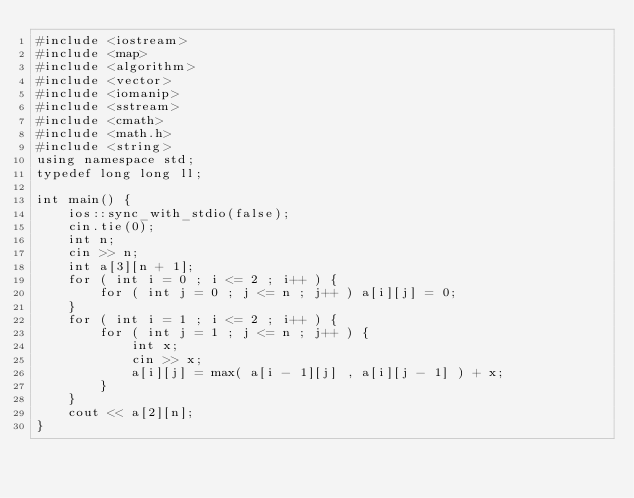Convert code to text. <code><loc_0><loc_0><loc_500><loc_500><_C++_>#include <iostream>
#include <map>
#include <algorithm>
#include <vector>
#include <iomanip>
#include <sstream>
#include <cmath>
#include <math.h>
#include <string>
using namespace std;
typedef long long ll;
 
int main() {
    ios::sync_with_stdio(false);
    cin.tie(0);
    int n;
    cin >> n;
    int a[3][n + 1];
    for ( int i = 0 ; i <= 2 ; i++ ) {
        for ( int j = 0 ; j <= n ; j++ ) a[i][j] = 0;
    }
    for ( int i = 1 ; i <= 2 ; i++ ) {
        for ( int j = 1 ; j <= n ; j++ ) {
            int x;
            cin >> x;
            a[i][j] = max( a[i - 1][j] , a[i][j - 1] ) + x;
        }
    }
    cout << a[2][n];
}

</code> 